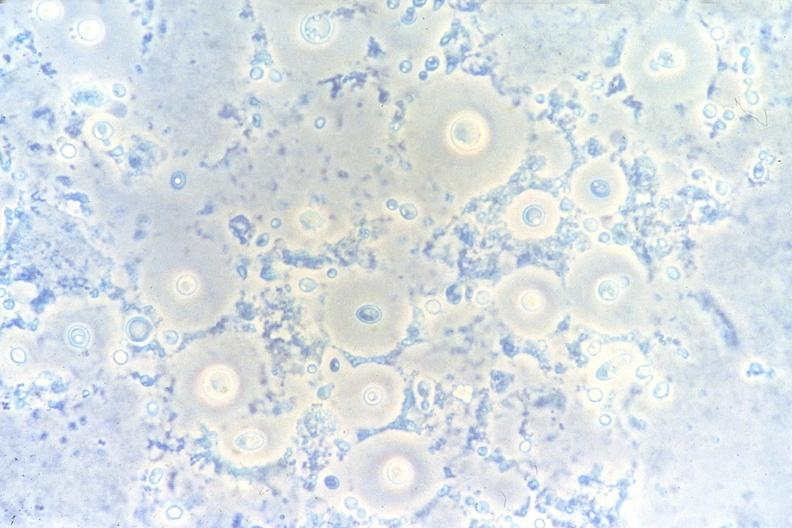what is present?
Answer the question using a single word or phrase. Respiratory 